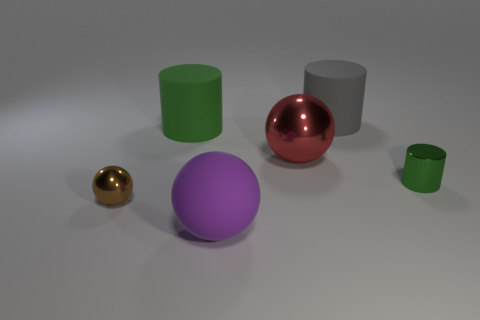Do the green matte object and the rubber ball have the same size?
Make the answer very short. Yes. What material is the green cylinder to the left of the purple sphere?
Make the answer very short. Rubber. How many other things are there of the same shape as the large green thing?
Provide a short and direct response. 2. Is the small green shiny thing the same shape as the gray rubber thing?
Make the answer very short. Yes. Are there any large green matte cylinders in front of the tiny brown thing?
Keep it short and to the point. No. How many things are either large gray objects or large blue metal objects?
Your answer should be compact. 1. How many other things are there of the same size as the brown thing?
Provide a succinct answer. 1. What number of big things are both on the right side of the red ball and in front of the green shiny cylinder?
Keep it short and to the point. 0. Is the size of the green cylinder that is on the left side of the gray object the same as the rubber object to the right of the large purple rubber thing?
Your answer should be very brief. Yes. There is a green object right of the large purple rubber object; how big is it?
Your answer should be compact. Small. 